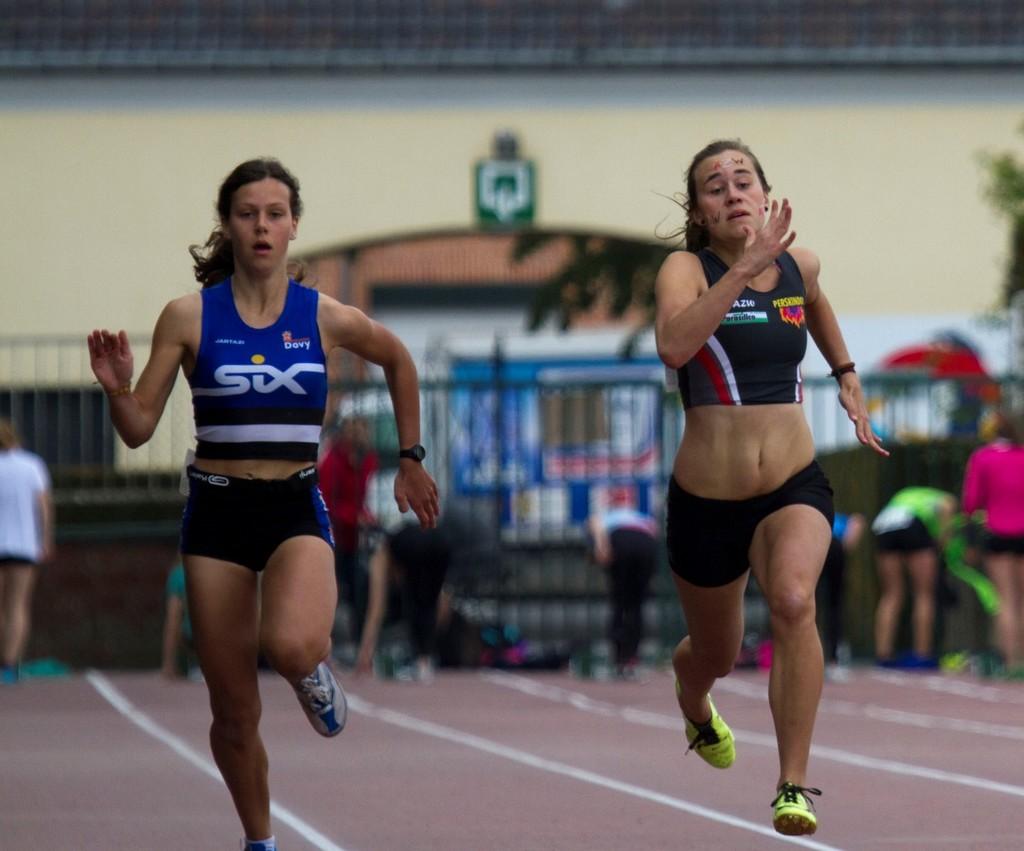Where is the runner with six on their shirt?
Ensure brevity in your answer.  Left. 